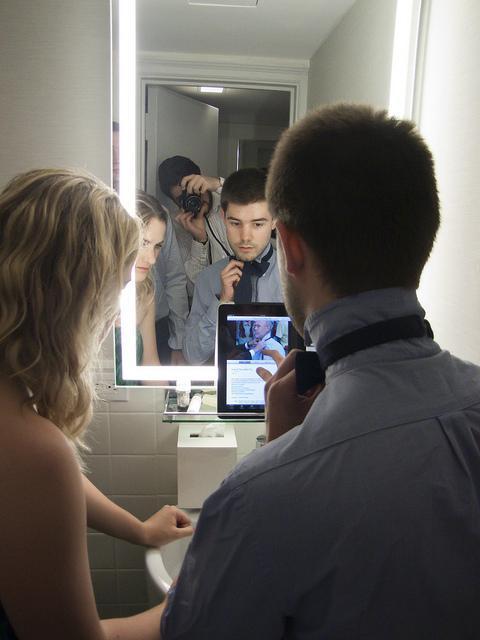How many people are there?
Give a very brief answer. 5. How many tines does the fork have?
Give a very brief answer. 0. 